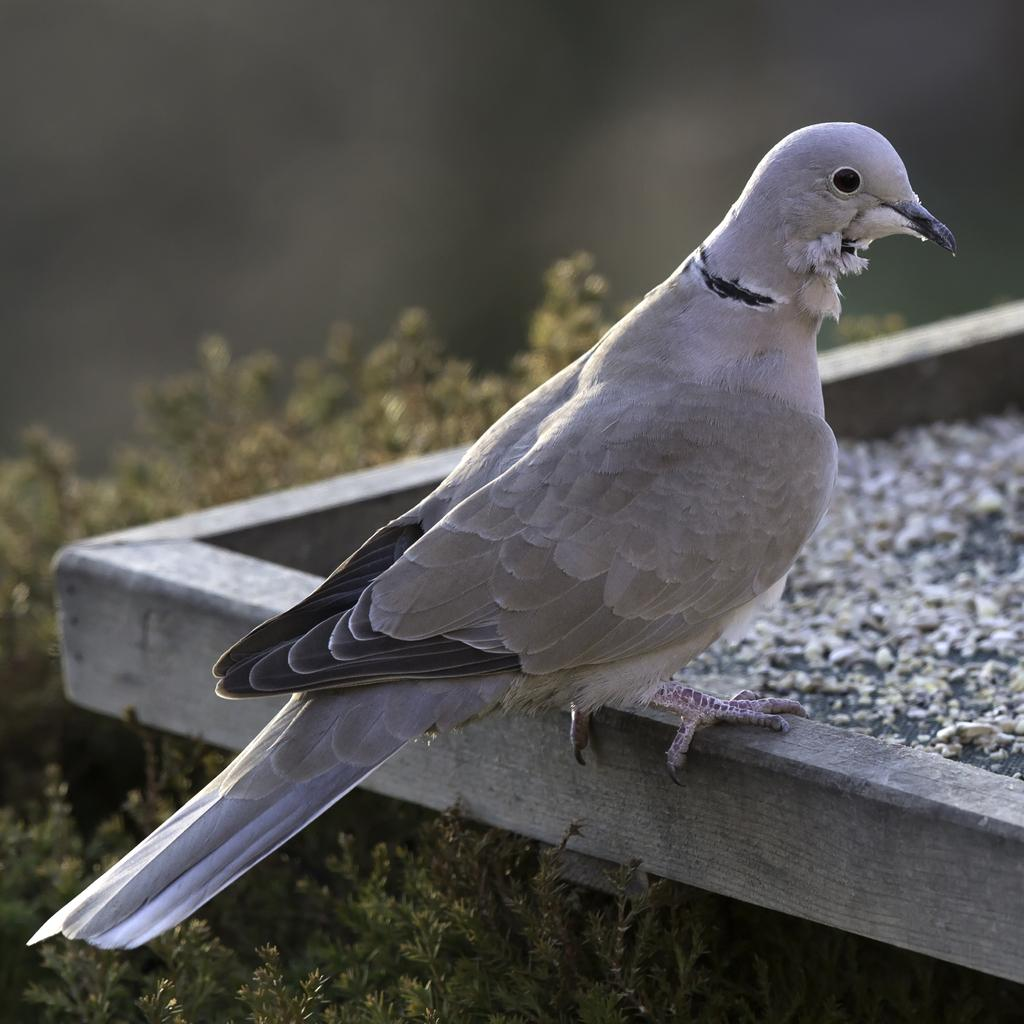What is the main subject in the center of the image? There is a pigeon in the center of the image. What can be seen at the bottom side of the image? There are plants at the bottom side of the image. How many legs does the rat have in the image? There is no rat present in the image, so it is not possible to determine the number of legs it might have. 